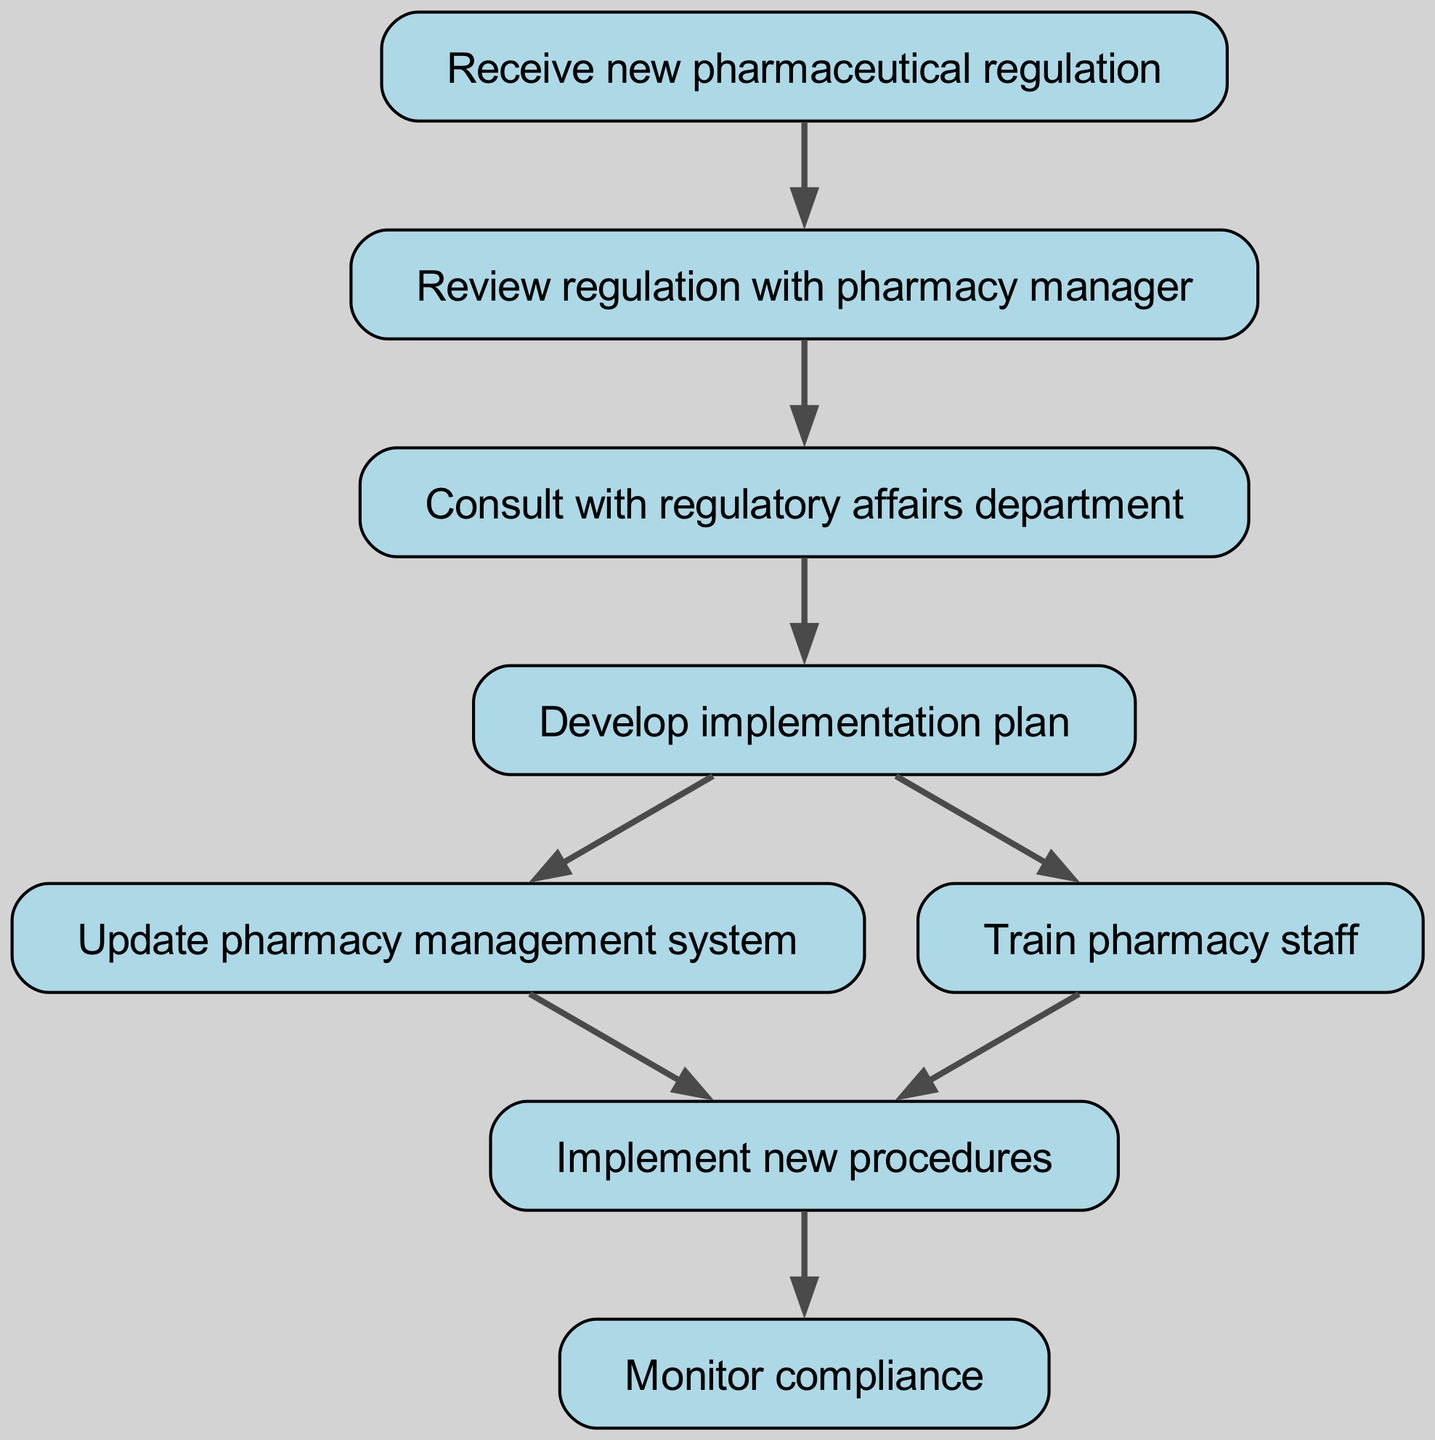What is the first step in the workflow? The first node in the workflow representation states "Receive new pharmaceutical regulation," indicating that this is the initial action to take when new regulations are introduced.
Answer: Receive new pharmaceutical regulation How many total nodes are there in the diagram? Counting the nodes listed, there are eight distinct steps in the workflow, which are indicated as nodes within the diagram.
Answer: 8 What is the second step following the reception of new regulations? After receiving the new regulation, the next step is "Review regulation with pharmacy manager," as shown directly connected to the first node.
Answer: Review regulation with pharmacy manager Which departments are consulted in the workflow? The diagram specifically indicates consultation with the "regulatory affairs department," which follows the review of regulations with the pharmacy manager.
Answer: Regulatory affairs department What steps are taken simultaneously after developing the implementation plan? The diagram shows that both "Update pharmacy management system" and "Train pharmacy staff" occur concurrently after the step of developing the implementation plan, as indicated by the two outgoing edges from that node.
Answer: Update pharmacy management system and Train pharmacy staff How many edges are present in the diagram? By counting each connection (arrows) between nodes, the diagram contains seven edges that illustrate the transitions from one step to another.
Answer: 7 What is the last action in the workflow? The concluding step of the workflow is "Monitor compliance," which is positioned at the end of the flow from the implementation of new procedures.
Answer: Monitor compliance At which point does staff training occur in the workflow? Staff training occurs after the implementation plan is developed, as indicated by the connection between those two specific nodes in the diagram.
Answer: After developing implementation plan What action follows the implementation of new procedures? The action that comes immediately after the implementation of new procedures is "Monitor compliance," as indicated in the flow chart.
Answer: Monitor compliance 